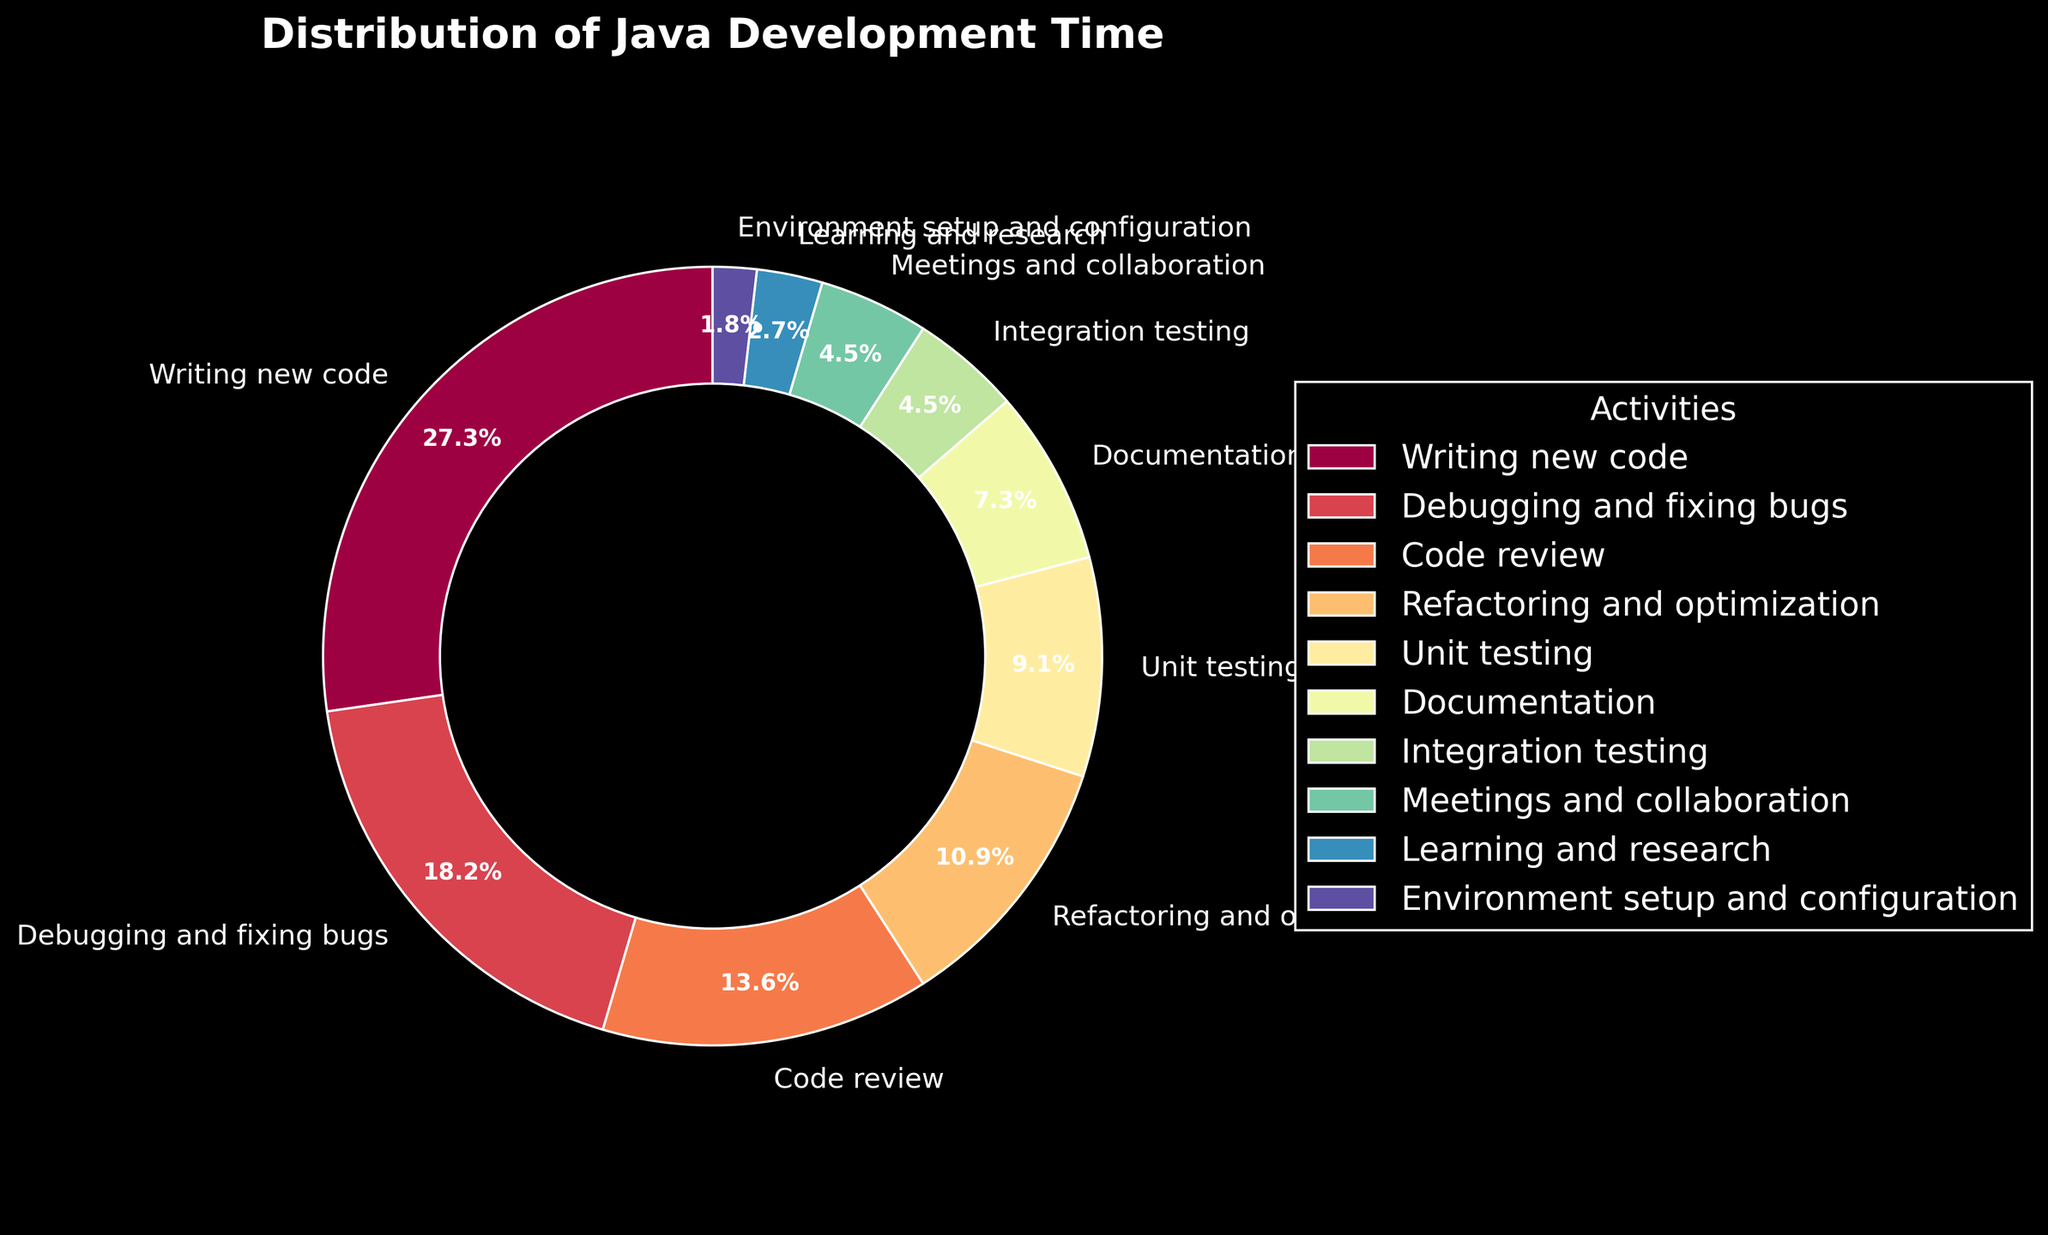What activity consumes the most development time? The activity with the highest percentage slice in the pie chart represents the activity that consumes the most development time. In the pie chart, 'Writing new code' has the largest slice at 30%.
Answer: Writing new code How much time is spent on debugging and fixing bugs compared to unit testing? To find this, we look at the respective percentages in the pie chart. 'Debugging and fixing bugs' takes 20%, while 'Unit testing' takes 10%.
Answer: 20% vs 10% Which activities together take up the smallest fraction of development time? We need to identify the activities with the smallest slices. 'Learning and research' (3%) and 'Environment setup and configuration' (2%) together make up the smallest fraction.
Answer: Learning and research, Environment setup and configuration What total percentage is spent on meetings and collaboration, and integration testing? Add the percentages for 'Meetings and collaboration' (5%) and 'Integration testing' (5%).
Answer: 10% Is more time spent on code review or refactoring and optimization? By looking at the pie chart, 'Code review' is 15% and 'Refactoring and optimization' is 12%.
Answer: Code review Which activity is represented by the darkest color in the pie chart? The pie chart uses a color gradient where certain activities have noticeably darker shades. The darkest color typically represents the smallest percentage. 'Environment setup and configuration' seems to have the darkest color.
Answer: Environment setup and configuration How much more time is spent on debugging and fixing bugs compared to writing documentation? Compare the percentages for 'Debugging and fixing bugs' (20%) and 'Documentation' (8%). Subtract the smaller percentage from the larger one. 20% - 8% = 12% more time is spent.
Answer: 12% Which activities combined make up exactly 25% of the time? Combine activities with their percentages until the sum is 25%. For example, 'Unit testing' (10%) and 'Documentation' (8%) together make 18%, adding 'Integration testing' (5%) makes it 23%, needing 'Environment setup and configuration' (2%) to reach exactly 25%.
Answer: Unit testing, Documentation, Integration testing, Environment setup and configuration What is the least time-consuming activity that is still more than 5% of development time? Identify the percentages greater than 5% and find the smallest value among them. 'Refactoring and optimization' is 12%, 'Unit testing' is 10%, 'Code review' is 15%. The smallest here is 'Unit testing' at 10%.
Answer: Unit testing What's the combined percentage of writing new code and code review? Add the percentages for 'Writing new code' (30%) and 'Code review' (15%). 30% + 15% = 45%.
Answer: 45% 